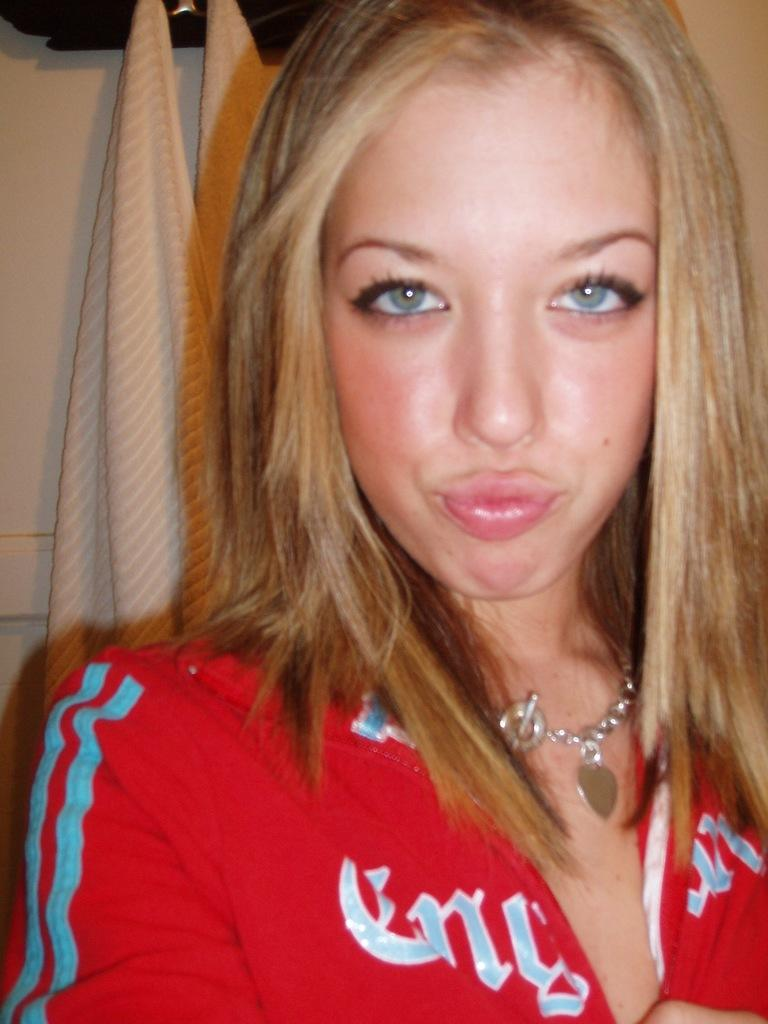Who is the main subject in the image? There is a woman in the image. What is the woman wearing? The woman is wearing red clothes and a necklace. What can be seen in the background of the image? There are clothes and other objects visible in the background of the image. What type of steel is being used to construct the growth in the image? There is no growth or steel present in the image; it features a woman wearing red clothes and a necklace. 